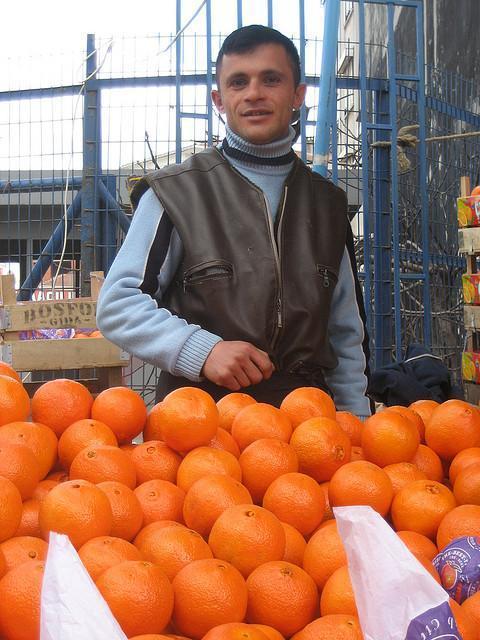How many oranges can you see?
Give a very brief answer. 10. 